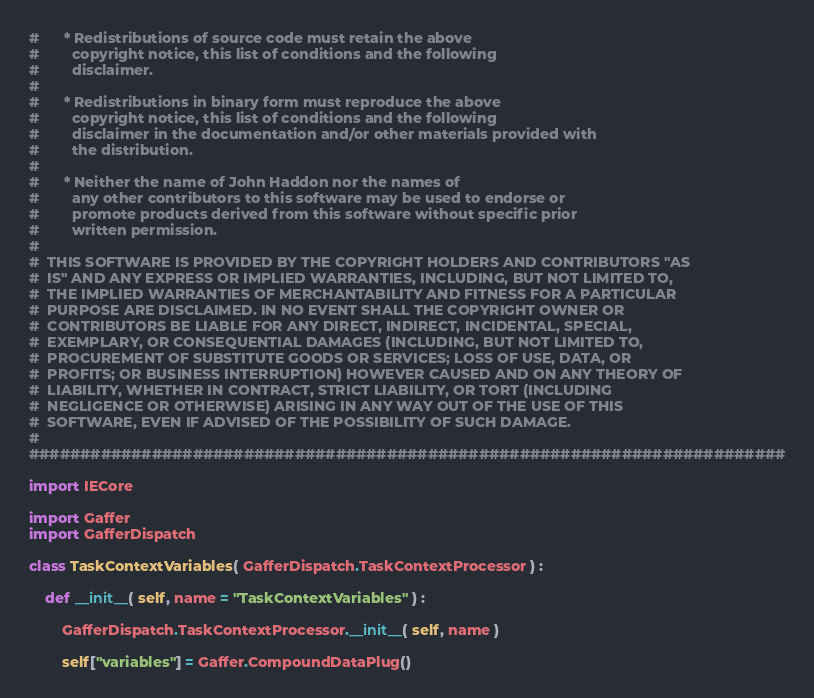<code> <loc_0><loc_0><loc_500><loc_500><_Python_>#      * Redistributions of source code must retain the above
#        copyright notice, this list of conditions and the following
#        disclaimer.
#
#      * Redistributions in binary form must reproduce the above
#        copyright notice, this list of conditions and the following
#        disclaimer in the documentation and/or other materials provided with
#        the distribution.
#
#      * Neither the name of John Haddon nor the names of
#        any other contributors to this software may be used to endorse or
#        promote products derived from this software without specific prior
#        written permission.
#
#  THIS SOFTWARE IS PROVIDED BY THE COPYRIGHT HOLDERS AND CONTRIBUTORS "AS
#  IS" AND ANY EXPRESS OR IMPLIED WARRANTIES, INCLUDING, BUT NOT LIMITED TO,
#  THE IMPLIED WARRANTIES OF MERCHANTABILITY AND FITNESS FOR A PARTICULAR
#  PURPOSE ARE DISCLAIMED. IN NO EVENT SHALL THE COPYRIGHT OWNER OR
#  CONTRIBUTORS BE LIABLE FOR ANY DIRECT, INDIRECT, INCIDENTAL, SPECIAL,
#  EXEMPLARY, OR CONSEQUENTIAL DAMAGES (INCLUDING, BUT NOT LIMITED TO,
#  PROCUREMENT OF SUBSTITUTE GOODS OR SERVICES; LOSS OF USE, DATA, OR
#  PROFITS; OR BUSINESS INTERRUPTION) HOWEVER CAUSED AND ON ANY THEORY OF
#  LIABILITY, WHETHER IN CONTRACT, STRICT LIABILITY, OR TORT (INCLUDING
#  NEGLIGENCE OR OTHERWISE) ARISING IN ANY WAY OUT OF THE USE OF THIS
#  SOFTWARE, EVEN IF ADVISED OF THE POSSIBILITY OF SUCH DAMAGE.
#
##########################################################################

import IECore

import Gaffer
import GafferDispatch

class TaskContextVariables( GafferDispatch.TaskContextProcessor ) :

	def __init__( self, name = "TaskContextVariables" ) :

		GafferDispatch.TaskContextProcessor.__init__( self, name )

		self["variables"] = Gaffer.CompoundDataPlug()
</code> 